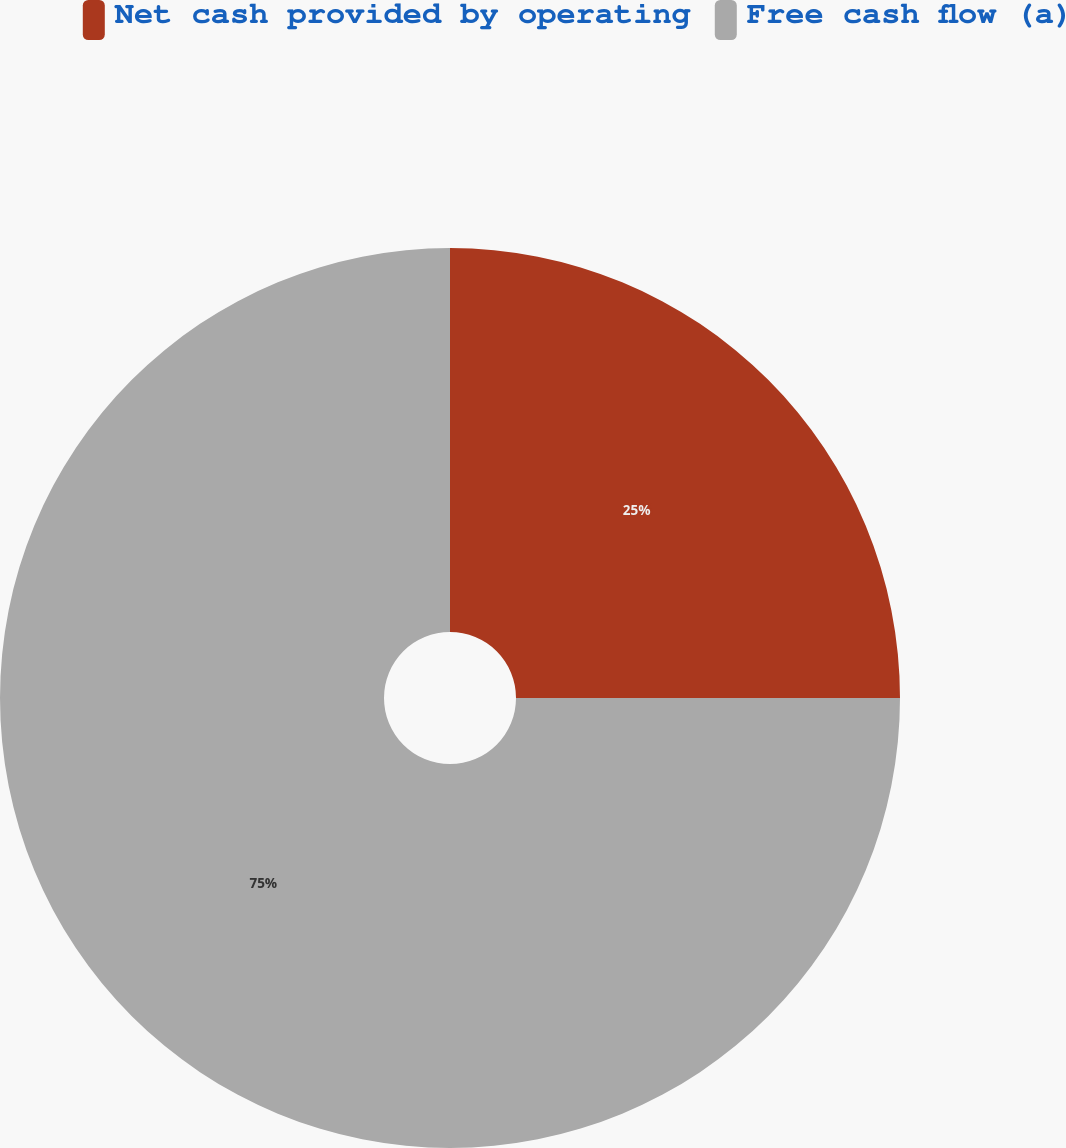Convert chart to OTSL. <chart><loc_0><loc_0><loc_500><loc_500><pie_chart><fcel>Net cash provided by operating<fcel>Free cash flow (a)<nl><fcel>25.0%<fcel>75.0%<nl></chart> 